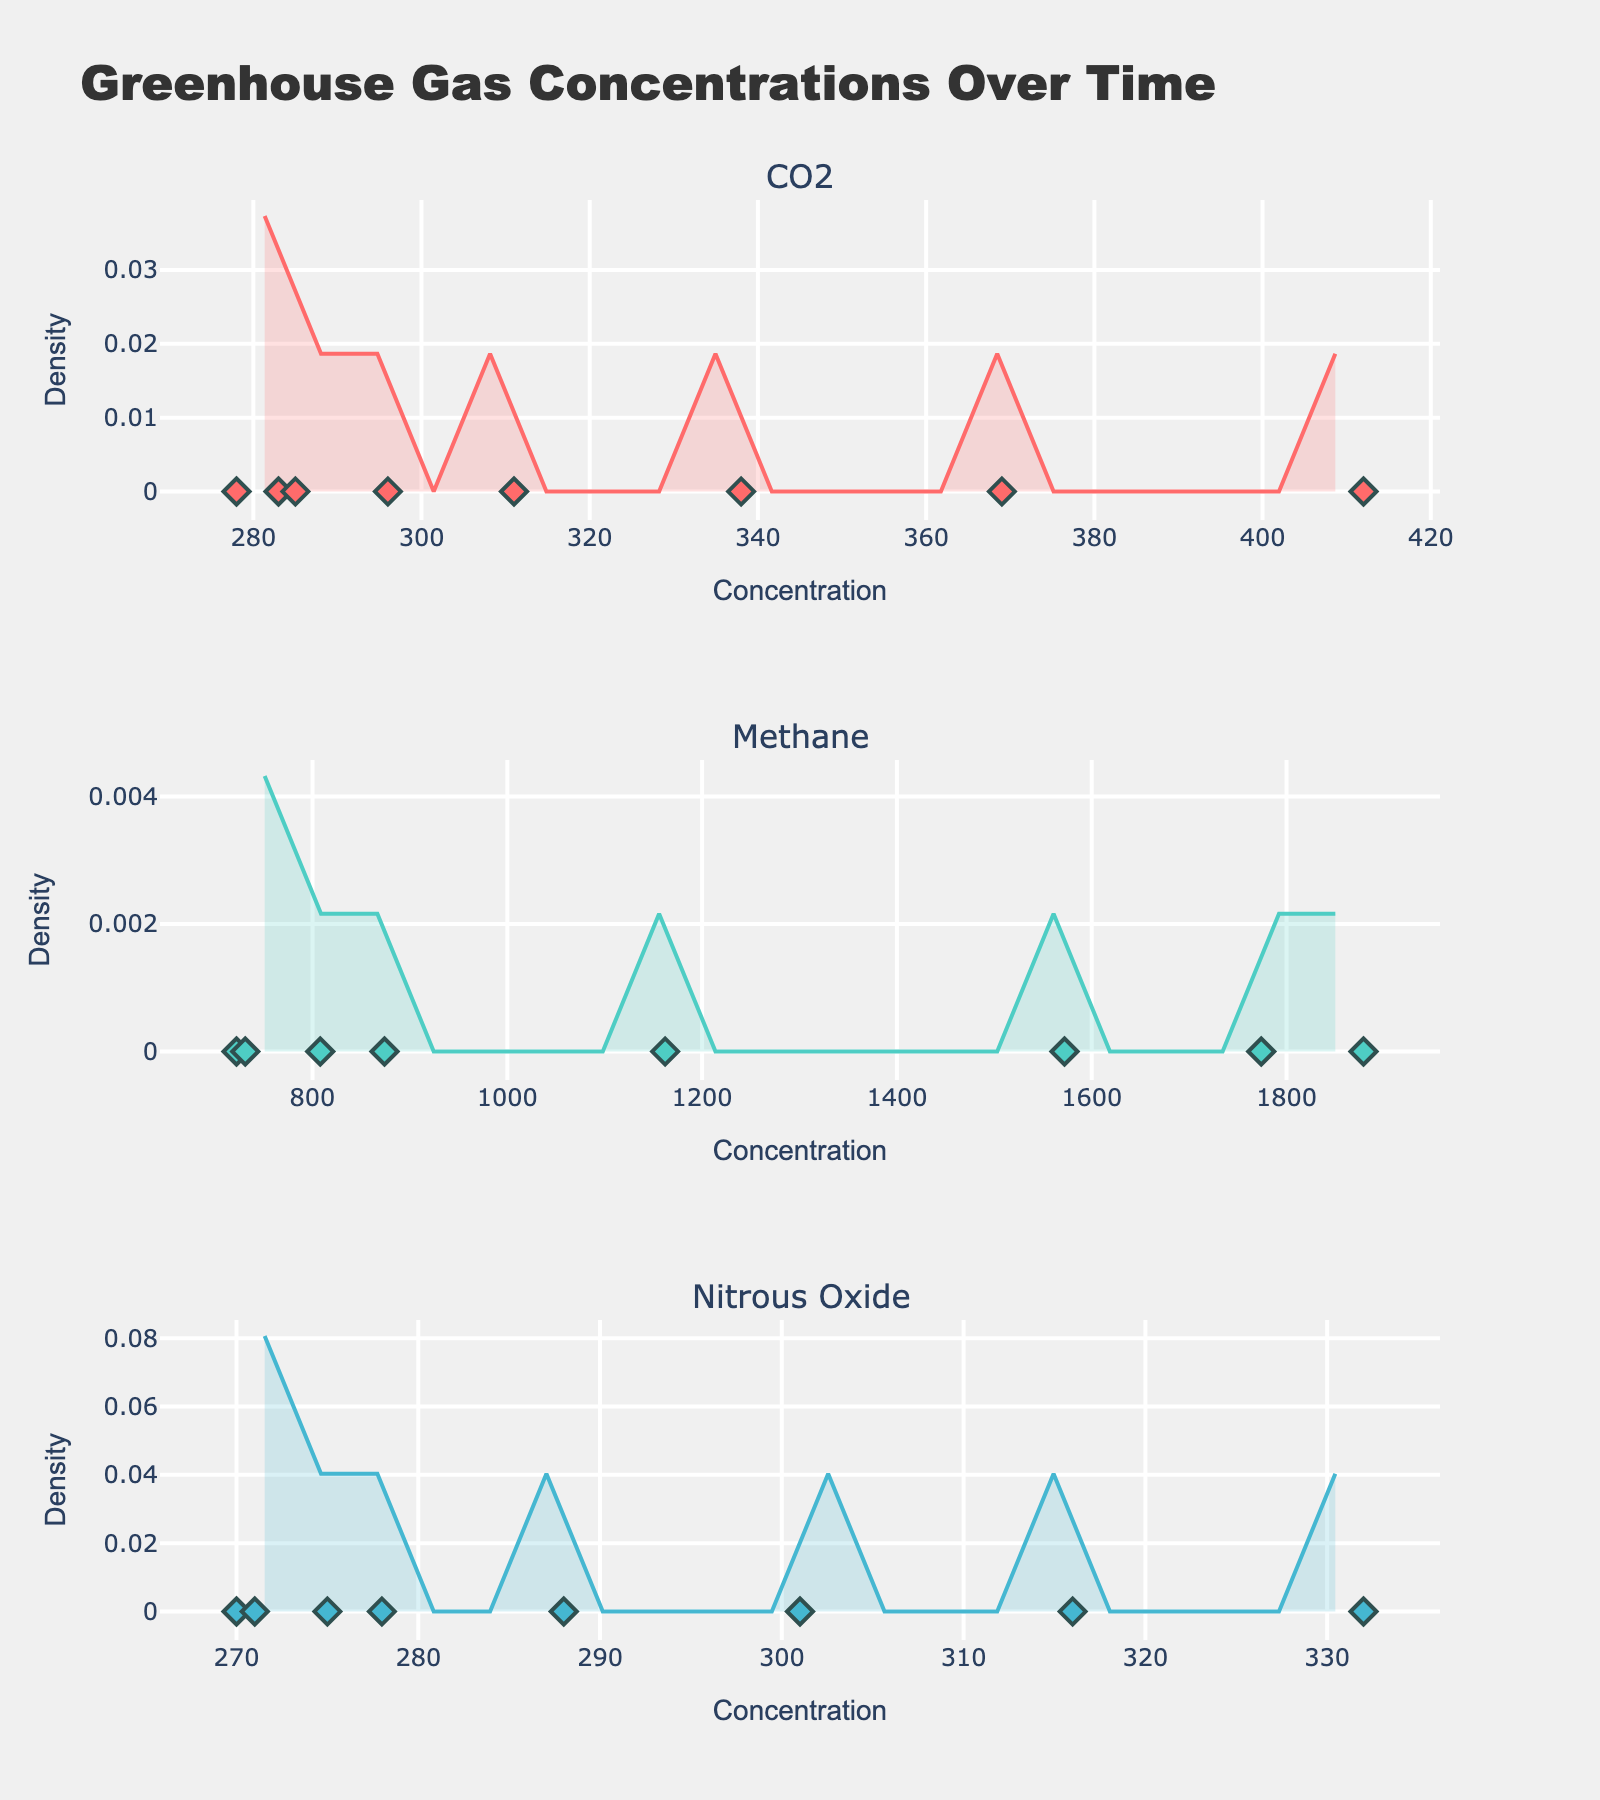Which gas shows the highest concentration in the latest year on the plot? Look at the density plots and locate the data points corresponding to the year 2020. The highest concentration can be observed by comparing the values.
Answer: CO2 What is the title of the figure? The title can be found at the top of the figure.
Answer: Greenhouse Gas Concentrations Over Time How many data points are there for CO2? Identify the number of CO2 concentration points on the scatter plot for CO2. Count the points.
Answer: 8 Which gas has the most spread-out density distribution? Compare the spread of the density plots (width and shape). The one with the widest spread is the answer.
Answer: Methane Compare the concentration trends of CO2 and Methane. Which one has shown a more significant increase over time? Look at the density and scatter plots for both gases. Identify the start and end concentrations and observe the overall increase.
Answer: Methane What color is used to represent the Nitrous Oxide gas in the plot? Identify the color of the density plot and the data points for Nitrous Oxide.
Answer: Blue Which gas reached a concentration of around 300 first based on the scatter plot? Look for the gas whose scatter plot first shows data points around 300.
Answer: CO2 Does any gas show a decline in concentration at any point on the plot? Examine the scatter and density plots for each gas to see if any of them have a decreasing trend at any point.
Answer: No What is the highest concentration level observed for Methane? Check the scatter plot for Methane and identify the highest data point.
Answer: 1879 Which gas has the highest density peak, and what is its approximate value? Look at the peaks of the density plots for each gas and identify the highest peak and its corresponding value.
Answer: CO2, around 0.15 